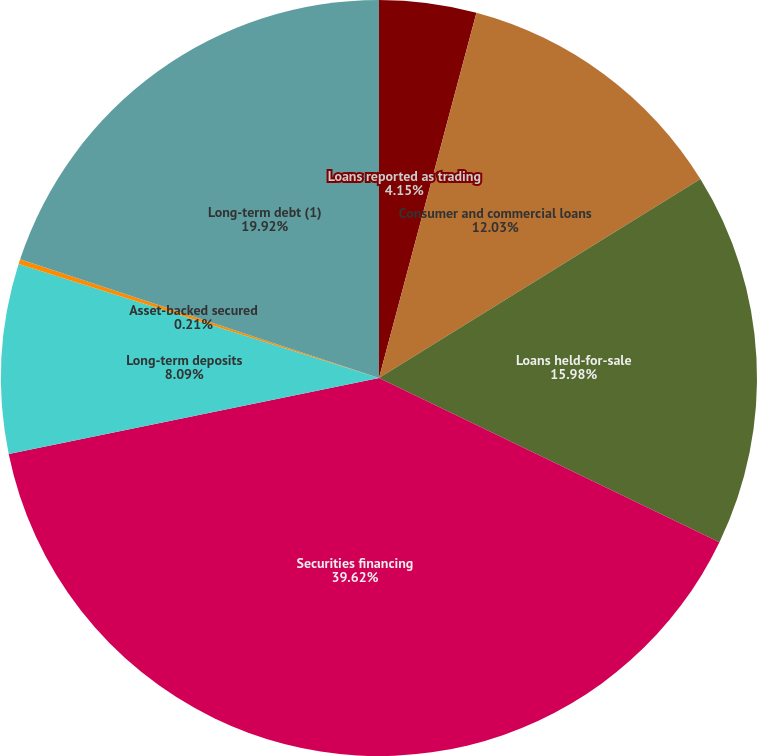Convert chart to OTSL. <chart><loc_0><loc_0><loc_500><loc_500><pie_chart><fcel>Loans reported as trading<fcel>Consumer and commercial loans<fcel>Loans held-for-sale<fcel>Securities financing<fcel>Long-term deposits<fcel>Asset-backed secured<fcel>Long-term debt (1)<nl><fcel>4.15%<fcel>12.03%<fcel>15.98%<fcel>39.63%<fcel>8.09%<fcel>0.21%<fcel>19.92%<nl></chart> 